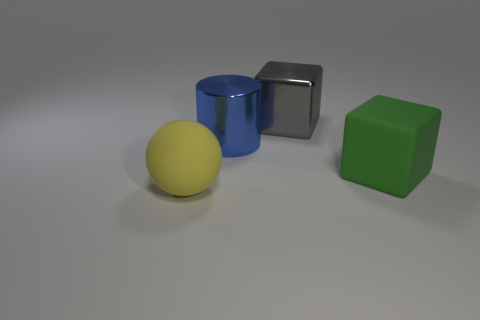Are there any things of the same color as the big sphere?
Provide a succinct answer. No. What is the size of the yellow sphere that is the same material as the green cube?
Ensure brevity in your answer.  Large. Is there anything else that is the same color as the big metal cylinder?
Provide a succinct answer. No. There is a large object that is behind the blue cylinder; what is its color?
Your response must be concise. Gray. There is a cube that is in front of the big cube behind the metallic cylinder; are there any blue metallic things in front of it?
Keep it short and to the point. No. Is the number of big green things that are on the left side of the big yellow thing greater than the number of big red rubber cylinders?
Ensure brevity in your answer.  No. There is a rubber thing that is on the left side of the large gray metal thing; is it the same shape as the big green rubber object?
Your response must be concise. No. Is there any other thing that has the same material as the big blue cylinder?
Your response must be concise. Yes. What number of objects are either tiny blue blocks or things that are behind the yellow rubber object?
Your response must be concise. 3. What size is the thing that is in front of the blue shiny thing and to the left of the big green thing?
Offer a very short reply. Large. 